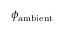Convert formula to latex. <formula><loc_0><loc_0><loc_500><loc_500>\phi _ { a m b i e n t }</formula> 